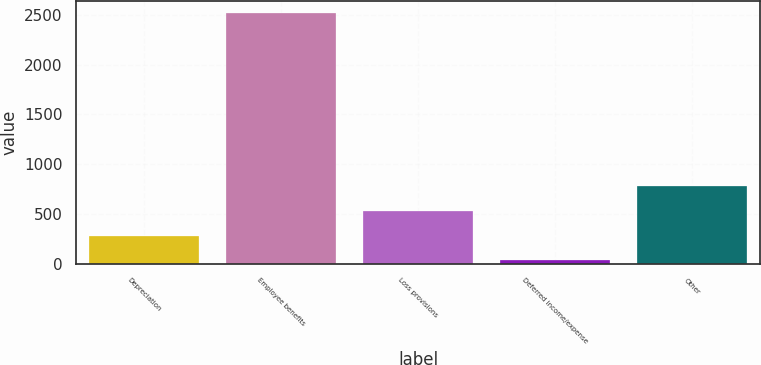<chart> <loc_0><loc_0><loc_500><loc_500><bar_chart><fcel>Depreciation<fcel>Employee benefits<fcel>Loss provisions<fcel>Deferred income/expense<fcel>Other<nl><fcel>285<fcel>2517<fcel>533<fcel>37<fcel>781<nl></chart> 